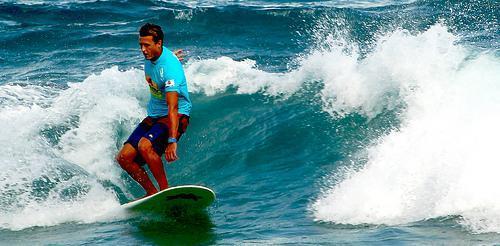How many people are pictured?
Give a very brief answer. 1. 